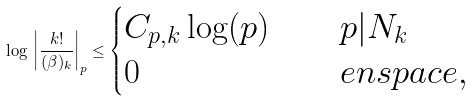Convert formula to latex. <formula><loc_0><loc_0><loc_500><loc_500>\log \, \left | \frac { k ! } { ( \beta ) _ { k } } \right | _ { p } \leq \begin{cases} C _ { p , k } \log ( p ) & \quad p | N _ { k } \\ 0 & \quad e n s p a c e , \end{cases}</formula> 